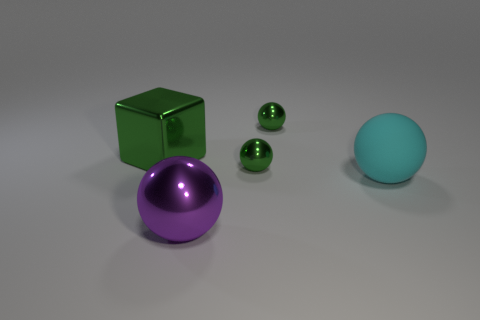Add 2 cyan spheres. How many objects exist? 7 Subtract all blocks. How many objects are left? 4 Subtract all tiny objects. Subtract all large cyan balls. How many objects are left? 2 Add 1 big green things. How many big green things are left? 2 Add 5 big brown metallic cubes. How many big brown metallic cubes exist? 5 Subtract 1 green blocks. How many objects are left? 4 